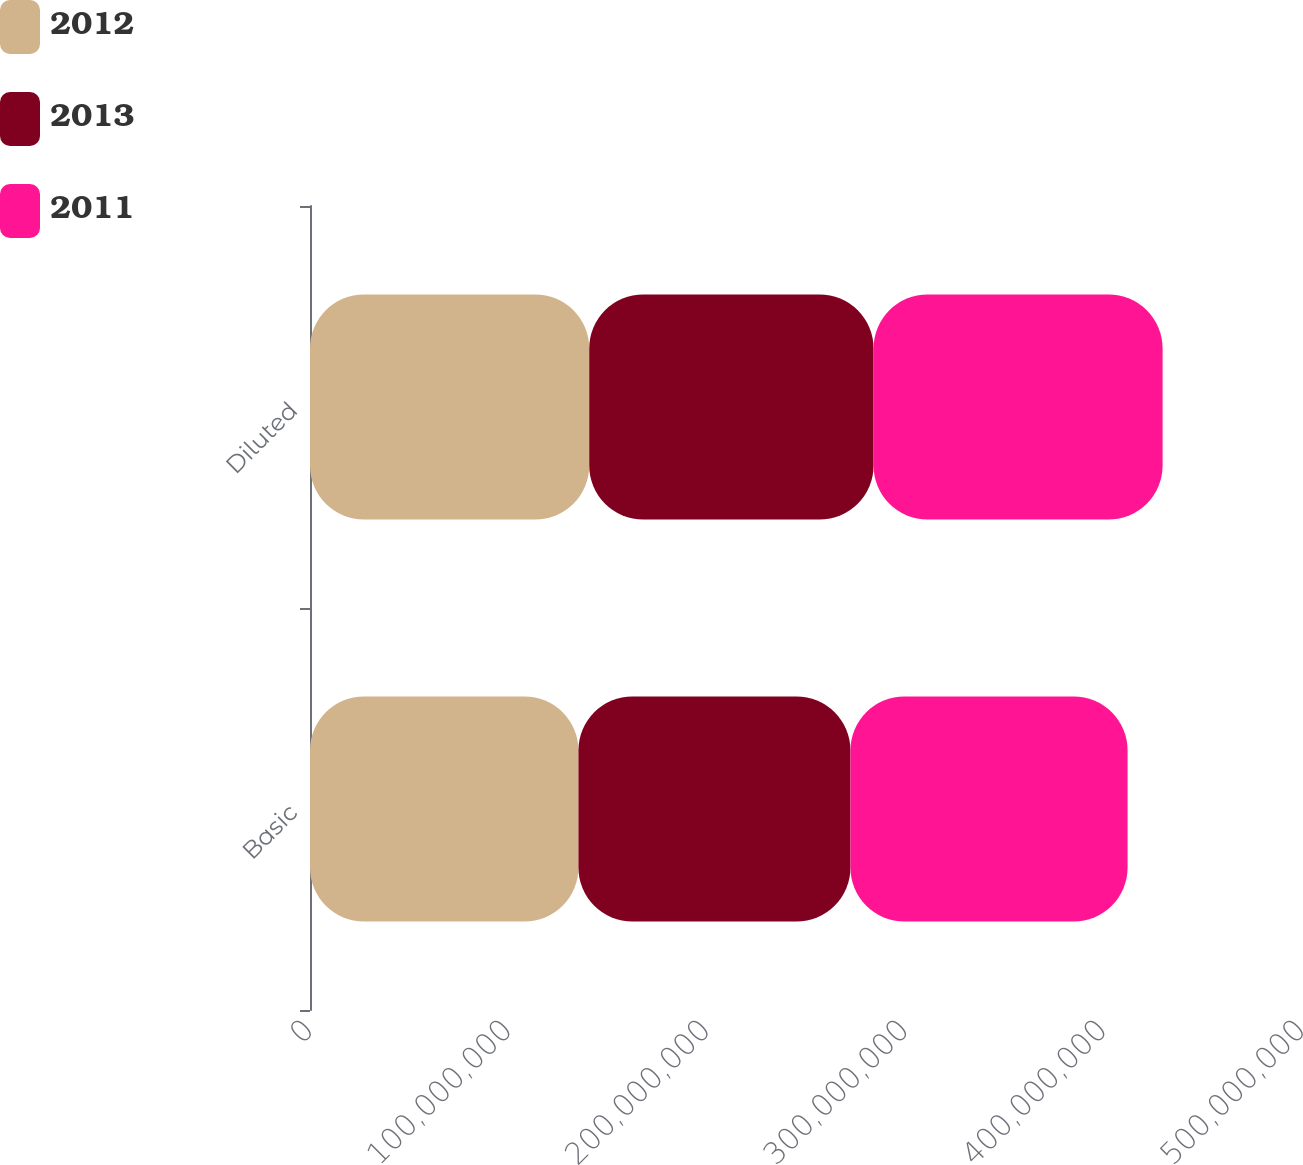<chart> <loc_0><loc_0><loc_500><loc_500><stacked_bar_chart><ecel><fcel>Basic<fcel>Diluted<nl><fcel>2012<fcel>1.35305e+08<fcel>1.40743e+08<nl><fcel>2013<fcel>1.37097e+08<fcel>1.43315e+08<nl><fcel>2011<fcel>1.39688e+08<fcel>1.45672e+08<nl></chart> 